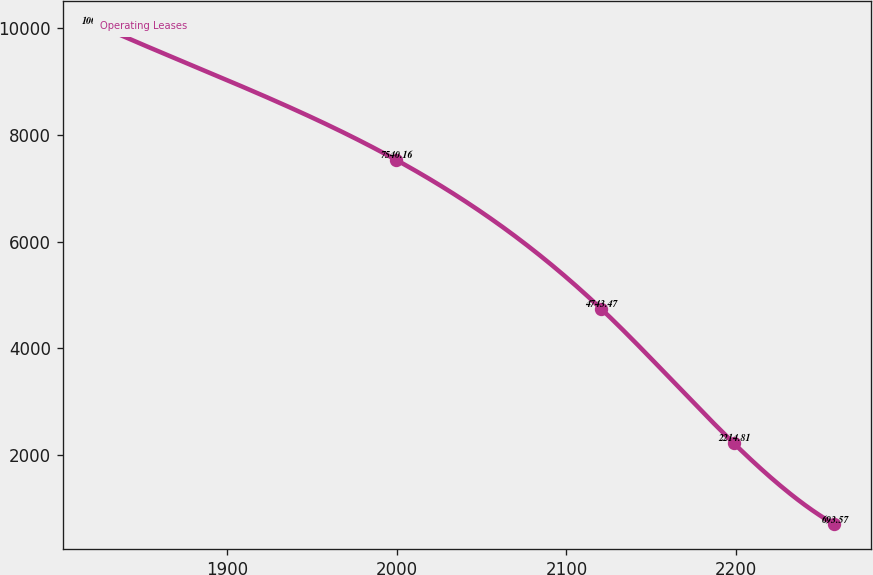Convert chart. <chart><loc_0><loc_0><loc_500><loc_500><line_chart><ecel><fcel>Operating Leases<nl><fcel>1824.97<fcel>10050.9<nl><fcel>1999.34<fcel>7540.16<nl><fcel>2120.29<fcel>4743.47<nl><fcel>2198.61<fcel>2214.81<nl><fcel>2257.8<fcel>693.57<nl></chart> 